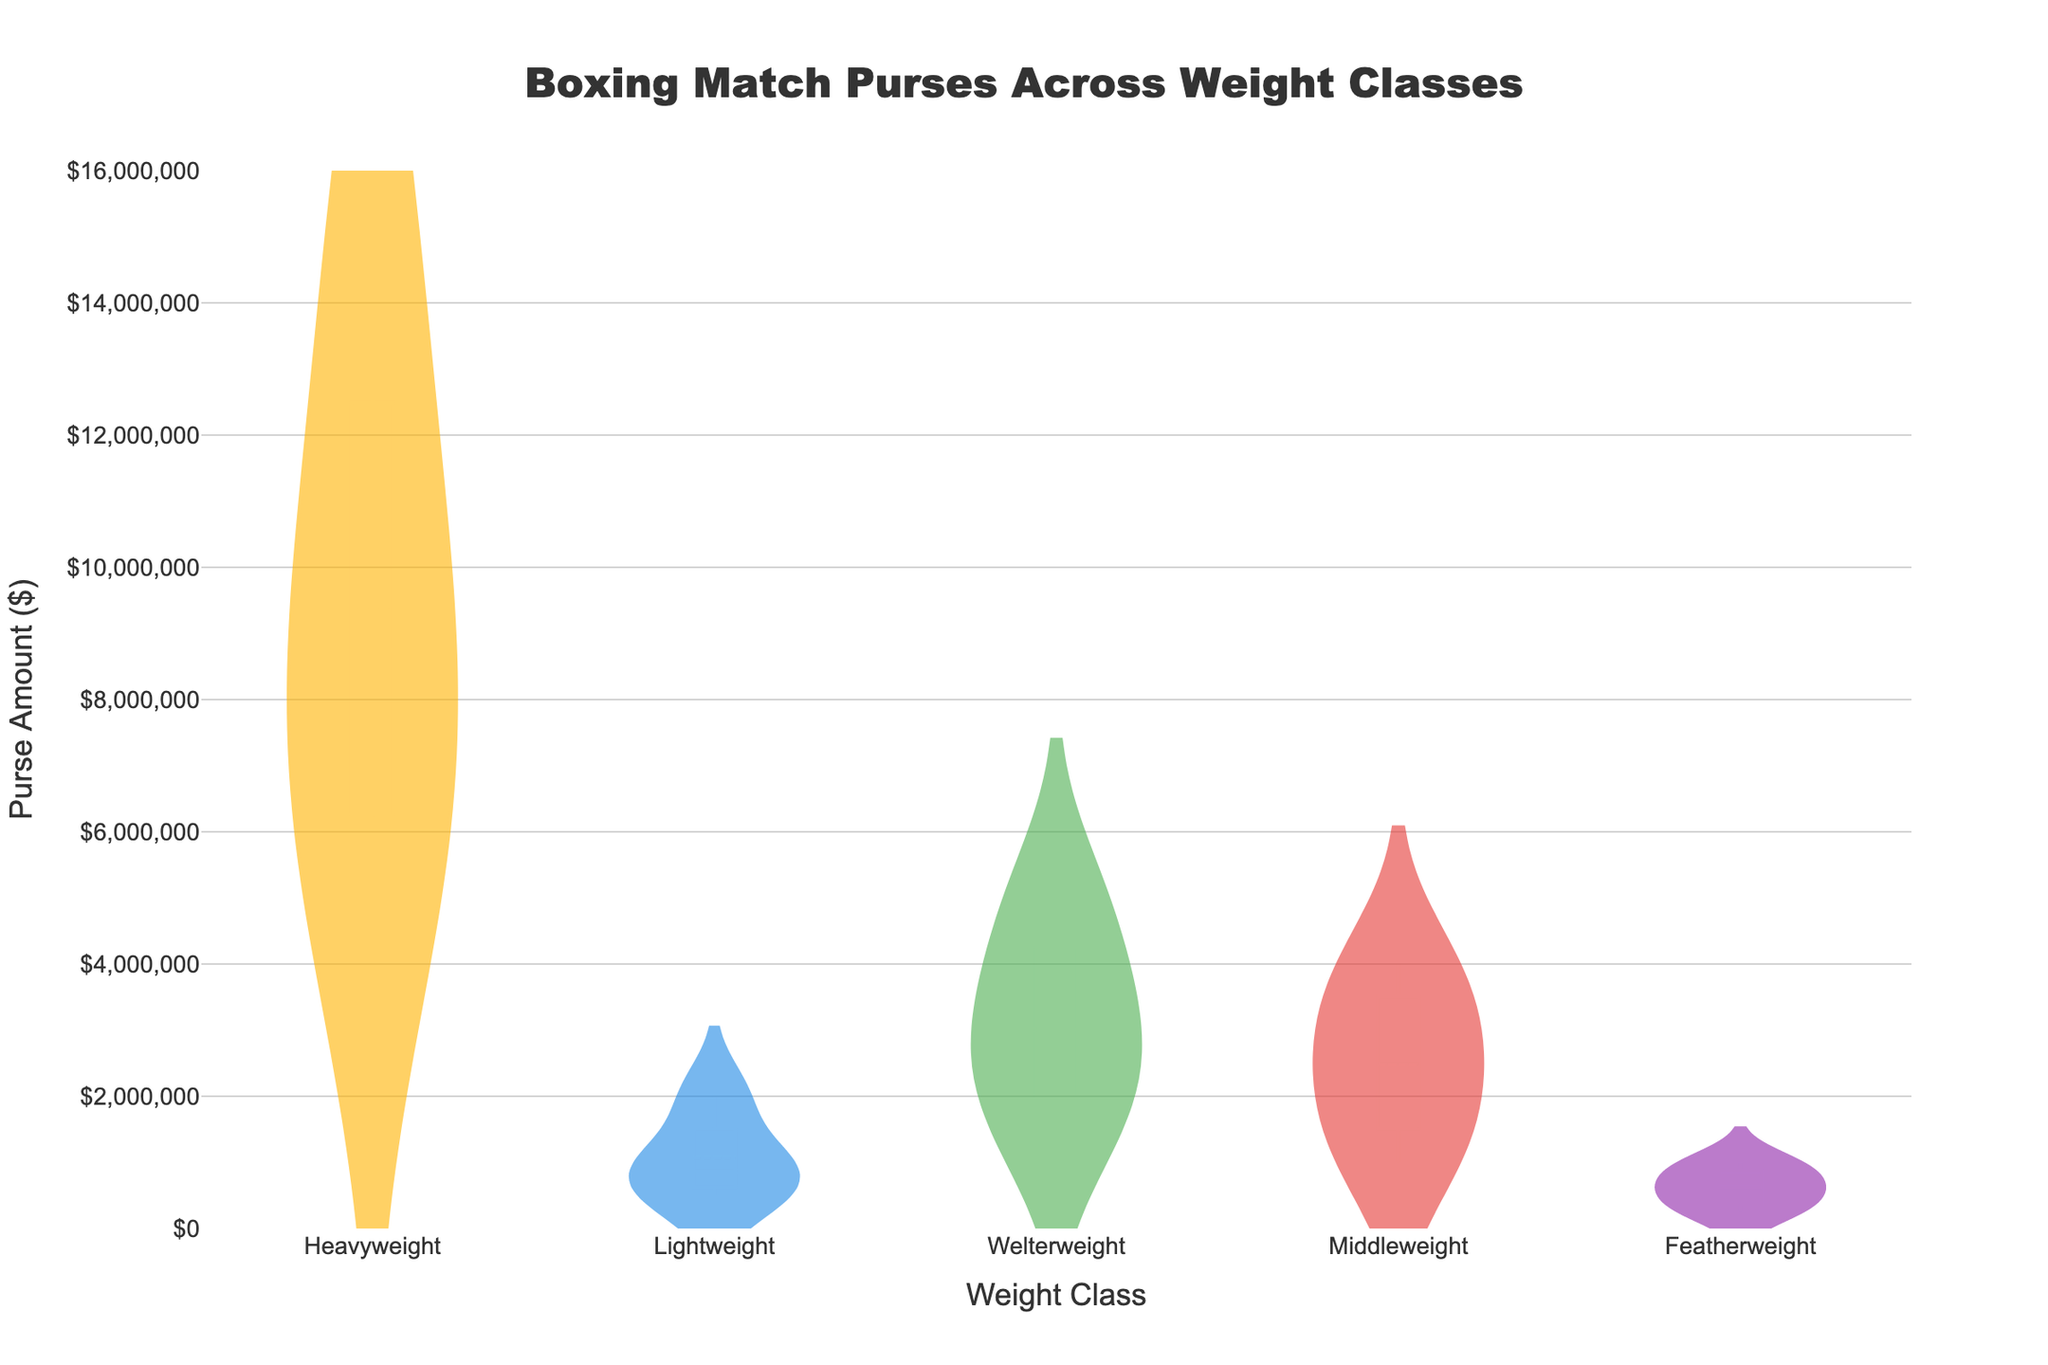What's the title of the figure? The title is displayed at the top of the figure. It helps viewers understand the main subject of the plot.
Answer: Boxing Match Purses Across Weight Classes What is the y-axis representing? The y-axis title indicates it represents the monetary amount associated with boxing match purses.
Answer: Purse Amount ($) Which weight class has the highest purse amount observed in the plot? By looking at the highest point on the density plot, we can see which weight class has the peak value, which represents the highest purse amount observed.
Answer: Heavyweight How do the median purse amounts for Featherweight and Lightweight compare? The median is indicated by a line within each density plot shape. Comparing the lines for Featherweight and Lightweight shows which one is higher or lower.
Answer: The median for Featherweight is lower than Lightweight Which weight class shows the most variation in purse amounts? The variation in purse amounts can be observed by the spread of each density plot. The wider and more spread out the plot, the more variation in the data.
Answer: Heavyweight What is the mean purse amount for Middleweight? The mean is indicated by a line within the density plot. Finding the mean line in the Middleweight plot gives the average purse amount for that class.
Answer: $2,500,000 Which weight classes have purse amounts that typically exceed $5,000,000? Observing the density plot, we can check which classes have significant data points or density above the $5,000,000 mark on the y-axis.
Answer: Heavyweight and Welterweight Do more weight classes have purse amounts below $2,000,000 or above $2,000,000? By visually inspecting the density plots' concentration areas relative to the $2,000,000 mark on the y-axis, we can determine where most data points lie.
Answer: Below $2,000,000 In which weight class does the majority of purse amounts fall within the range of $1,500,000 to $4,000,000? By observing the densest part of the density plots within this specific range, we can identify the weight class with the majority of its data points in that range.
Answer: Welterweight 